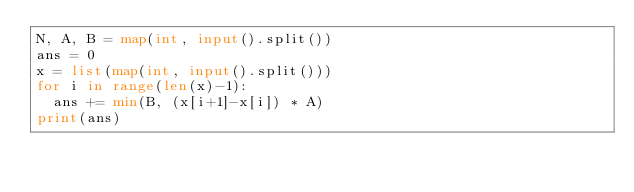<code> <loc_0><loc_0><loc_500><loc_500><_Python_>N, A, B = map(int, input().split())
ans = 0
x = list(map(int, input().split()))
for i in range(len(x)-1):
  ans += min(B, (x[i+1]-x[i]) * A)
print(ans)</code> 